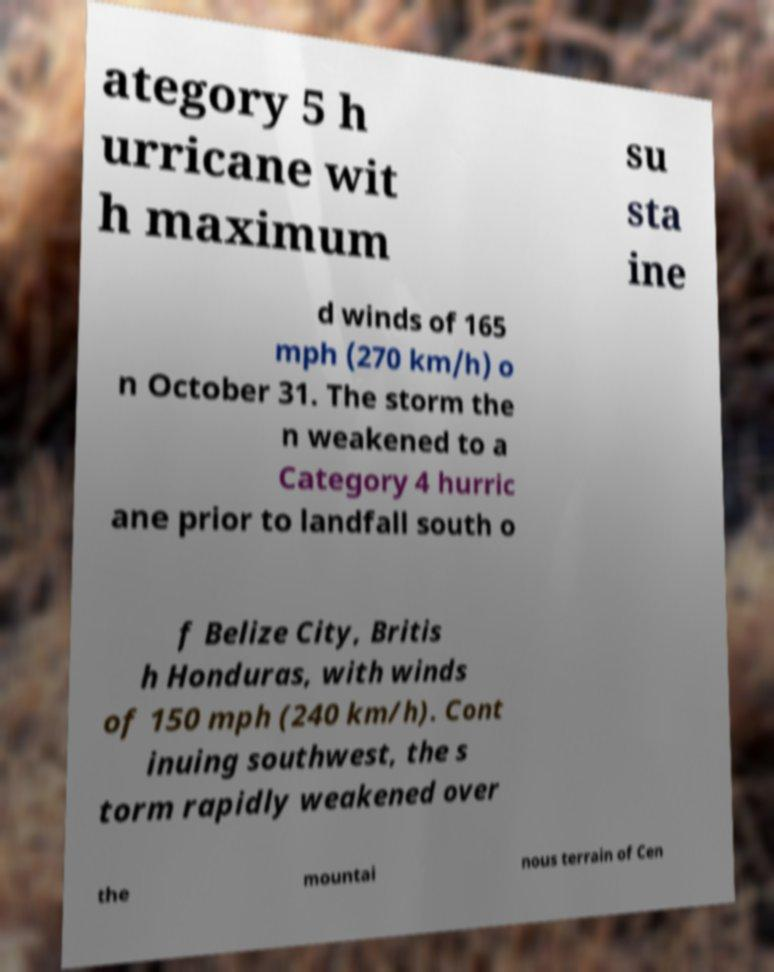What messages or text are displayed in this image? I need them in a readable, typed format. ategory 5 h urricane wit h maximum su sta ine d winds of 165 mph (270 km/h) o n October 31. The storm the n weakened to a Category 4 hurric ane prior to landfall south o f Belize City, Britis h Honduras, with winds of 150 mph (240 km/h). Cont inuing southwest, the s torm rapidly weakened over the mountai nous terrain of Cen 